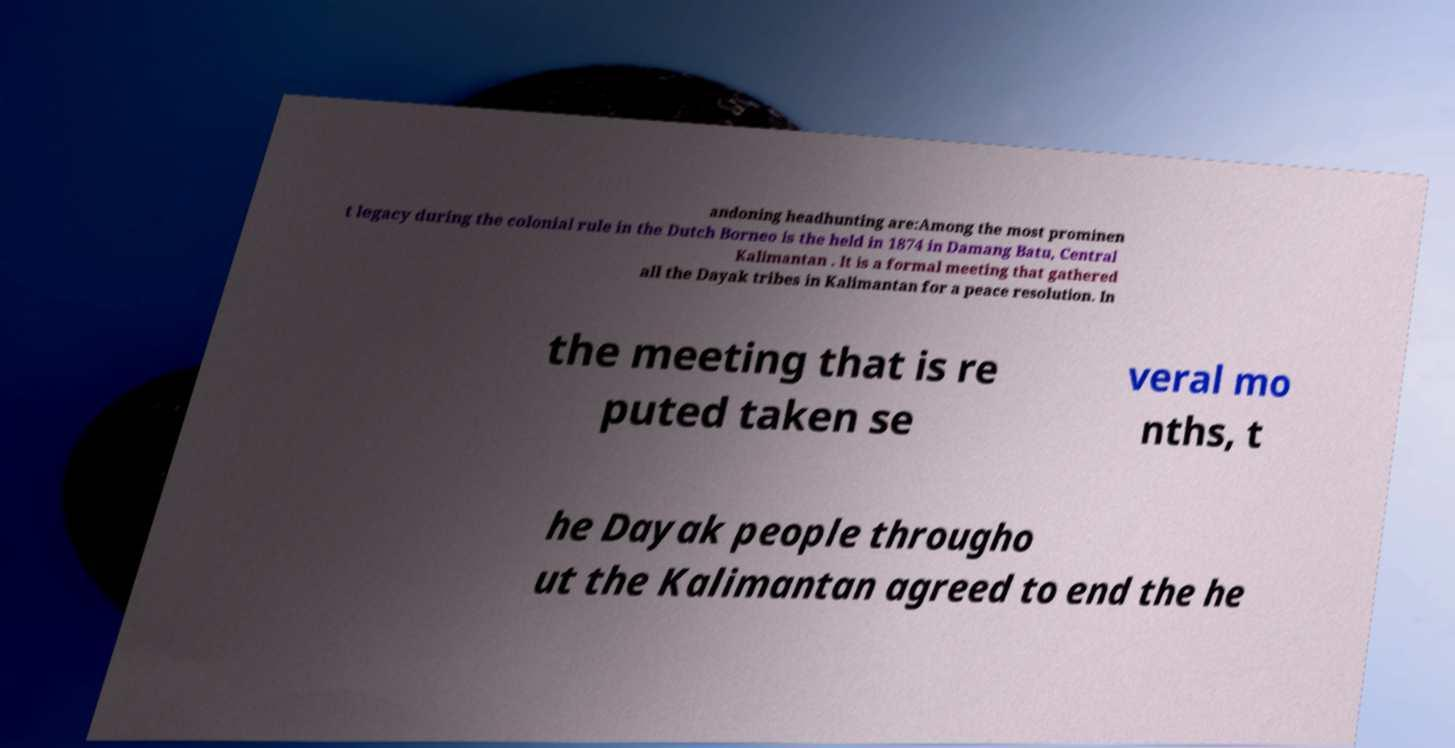Could you assist in decoding the text presented in this image and type it out clearly? andoning headhunting are:Among the most prominen t legacy during the colonial rule in the Dutch Borneo is the held in 1874 in Damang Batu, Central Kalimantan . It is a formal meeting that gathered all the Dayak tribes in Kalimantan for a peace resolution. In the meeting that is re puted taken se veral mo nths, t he Dayak people througho ut the Kalimantan agreed to end the he 